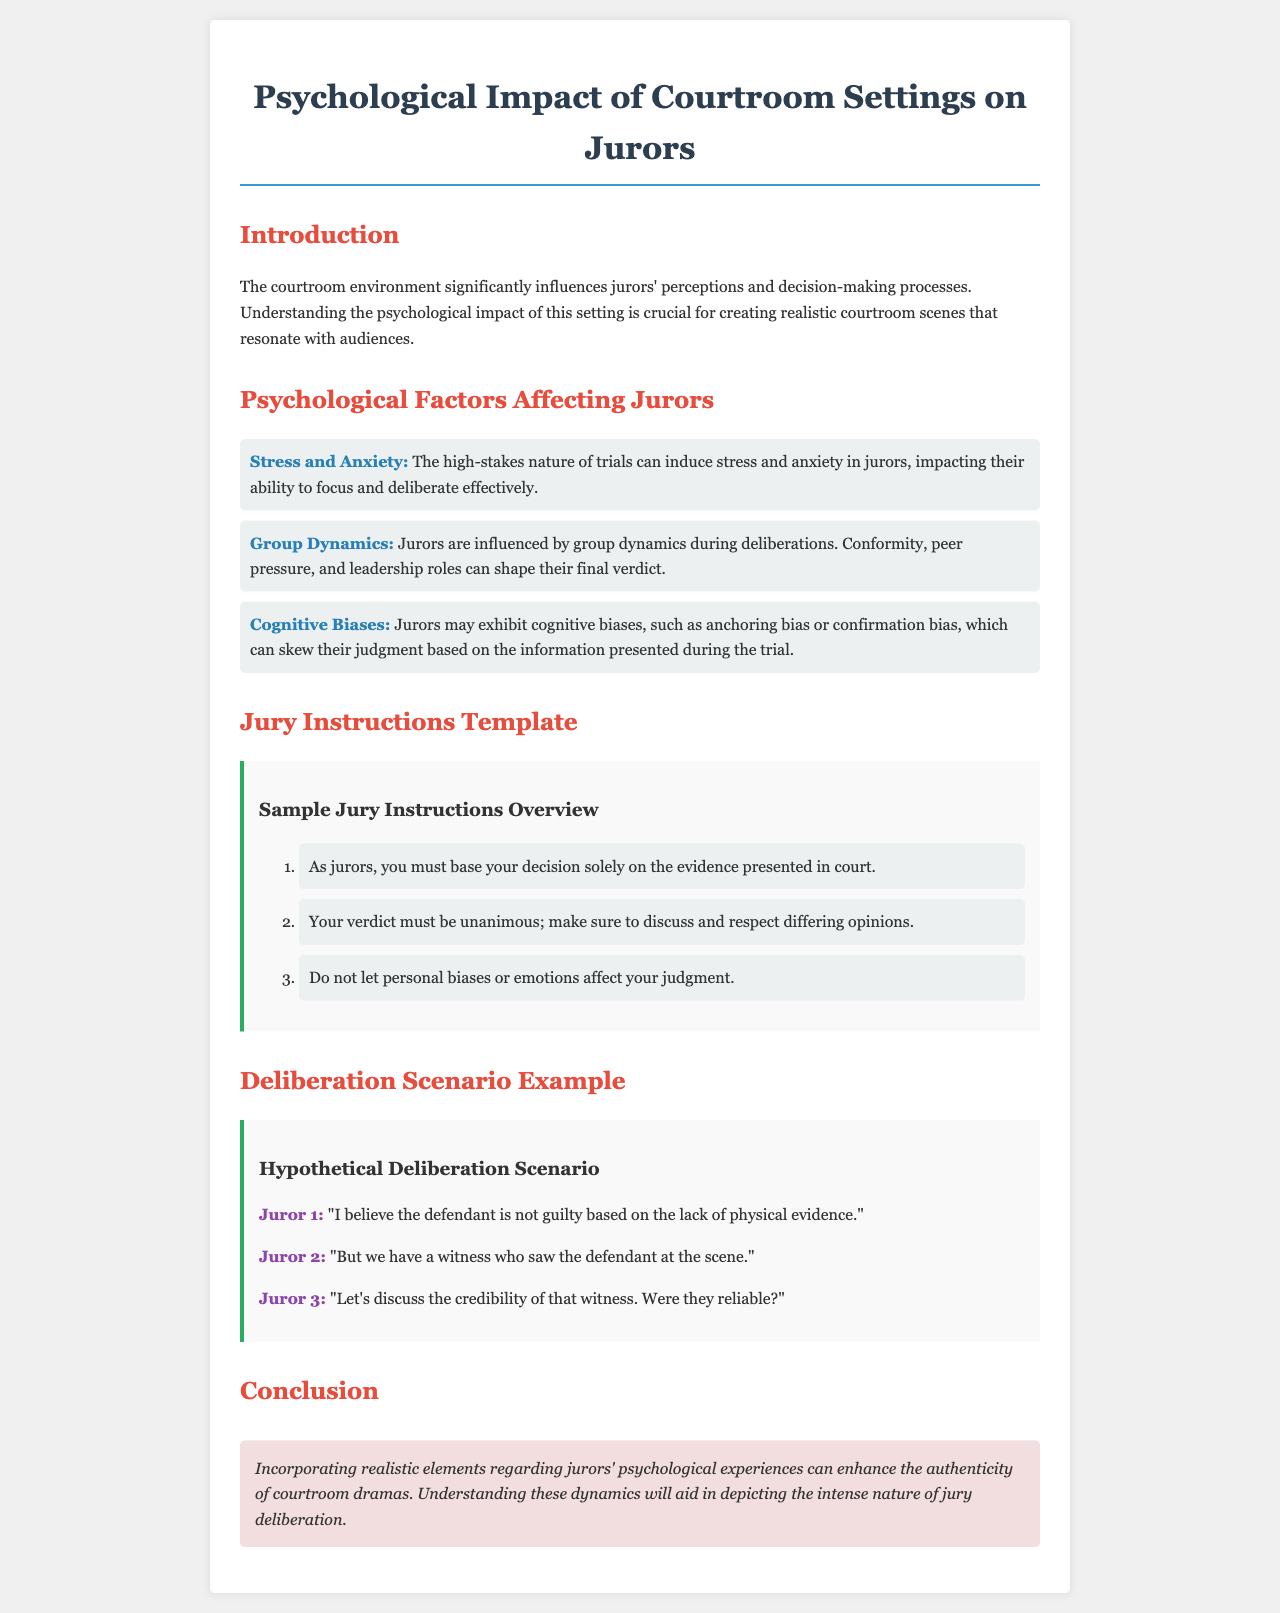What are the three psychological factors affecting jurors? The document lists three psychological factors affecting jurors: Stress and Anxiety, Group Dynamics, and Cognitive Biases.
Answer: Stress and Anxiety, Group Dynamics, Cognitive Biases How many points are in the jury instructions template? The jury instructions template contains three numbered points for jurors to follow.
Answer: 3 What is the hypothetical statement made by Juror 1 in the deliberation scenario? Juror 1 states, "I believe the defendant is not guilty based on the lack of physical evidence."
Answer: "I believe the defendant is not guilty based on the lack of physical evidence." What psychological impact does the courtroom environment have on jurors? The document states that the courtroom environment significantly influences jurors' perceptions and decision-making processes.
Answer: Influences perceptions and decision-making processes What role does group dynamics play in deliberations? Group dynamics can lead to conformity, peer pressure, and leadership roles that shape jurors' final verdicts.
Answer: Shapes final verdicts Which color is associated with the heading of the document? The heading of the document is associated with the color #2c3e50.
Answer: #2c3e50 What should jurors do regarding personal biases? Jurors are instructed not to let personal biases or emotions affect their judgment.
Answer: Not let personal biases affect judgment What is the conclusion of the document focused on? The conclusion emphasizes the importance of incorporating realistic elements regarding jurors' psychological experiences.
Answer: Incorporating realistic elements regarding jurors' psychological experiences 